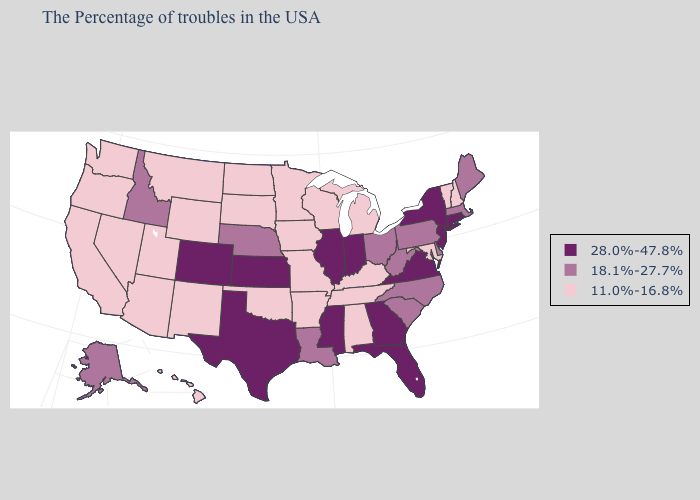Does Kansas have a lower value than Montana?
Answer briefly. No. Name the states that have a value in the range 28.0%-47.8%?
Concise answer only. Rhode Island, Connecticut, New York, New Jersey, Virginia, Florida, Georgia, Indiana, Illinois, Mississippi, Kansas, Texas, Colorado. Name the states that have a value in the range 11.0%-16.8%?
Be succinct. New Hampshire, Vermont, Maryland, Michigan, Kentucky, Alabama, Tennessee, Wisconsin, Missouri, Arkansas, Minnesota, Iowa, Oklahoma, South Dakota, North Dakota, Wyoming, New Mexico, Utah, Montana, Arizona, Nevada, California, Washington, Oregon, Hawaii. Among the states that border Iowa , does Missouri have the highest value?
Be succinct. No. Does Oregon have a lower value than Louisiana?
Short answer required. Yes. How many symbols are there in the legend?
Write a very short answer. 3. Name the states that have a value in the range 28.0%-47.8%?
Short answer required. Rhode Island, Connecticut, New York, New Jersey, Virginia, Florida, Georgia, Indiana, Illinois, Mississippi, Kansas, Texas, Colorado. What is the value of New York?
Concise answer only. 28.0%-47.8%. What is the value of Maryland?
Quick response, please. 11.0%-16.8%. Does North Carolina have a higher value than Iowa?
Quick response, please. Yes. What is the value of Alabama?
Answer briefly. 11.0%-16.8%. Name the states that have a value in the range 11.0%-16.8%?
Short answer required. New Hampshire, Vermont, Maryland, Michigan, Kentucky, Alabama, Tennessee, Wisconsin, Missouri, Arkansas, Minnesota, Iowa, Oklahoma, South Dakota, North Dakota, Wyoming, New Mexico, Utah, Montana, Arizona, Nevada, California, Washington, Oregon, Hawaii. Name the states that have a value in the range 18.1%-27.7%?
Write a very short answer. Maine, Massachusetts, Delaware, Pennsylvania, North Carolina, South Carolina, West Virginia, Ohio, Louisiana, Nebraska, Idaho, Alaska. What is the lowest value in states that border South Dakota?
Short answer required. 11.0%-16.8%. 